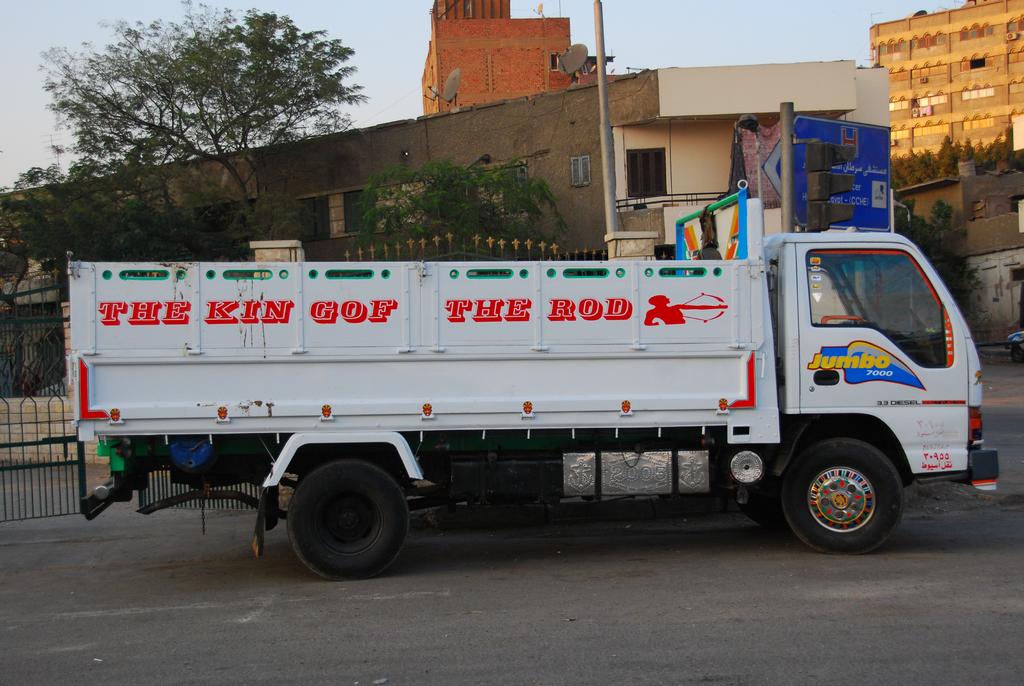Who is the king of the rod?
Your answer should be very brief. Jumbo. What is written in yellow letters on the door?
Your answer should be very brief. Jumbo. 